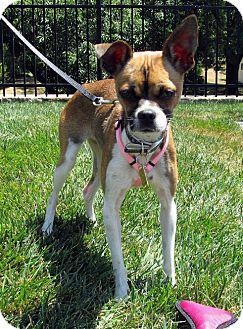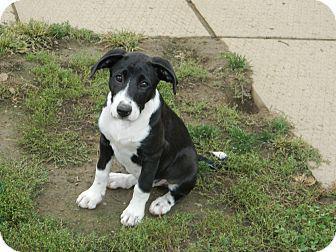The first image is the image on the left, the second image is the image on the right. For the images shown, is this caption "The dog in the image on the right is sitting in the grass outside." true? Answer yes or no. Yes. The first image is the image on the left, the second image is the image on the right. For the images displayed, is the sentence "The dog on the left wears a collar and stands on all fours, and the dog on the right is in a grassy spot and has black-and-white coloring." factually correct? Answer yes or no. Yes. 